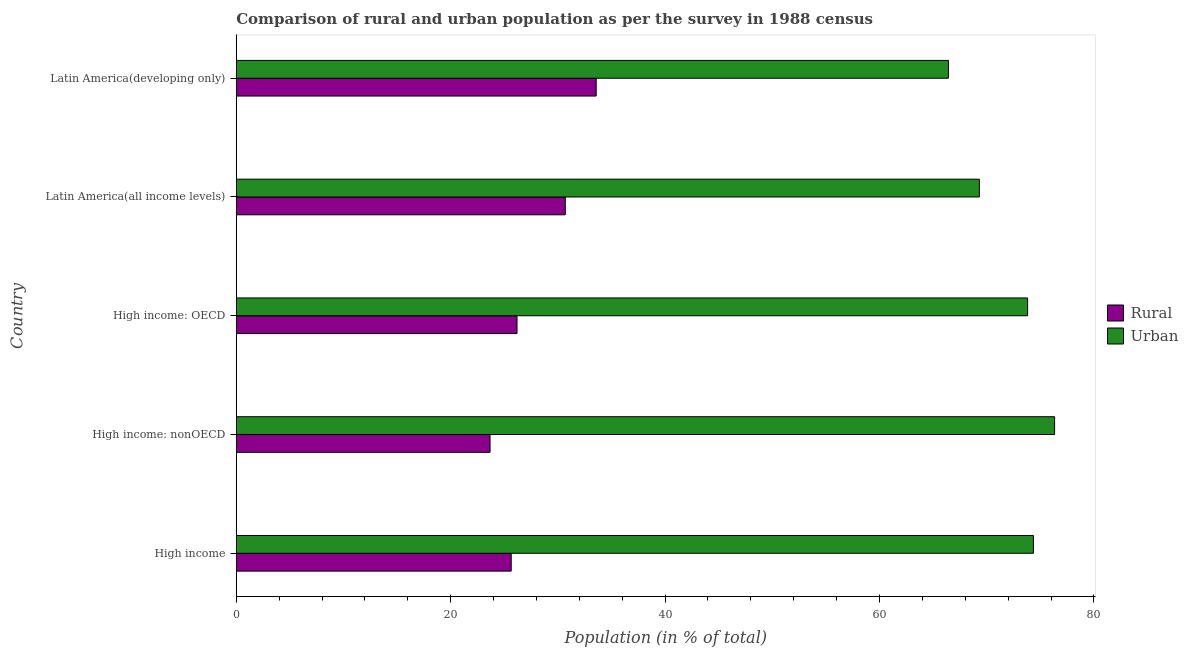How many different coloured bars are there?
Offer a terse response. 2. Are the number of bars per tick equal to the number of legend labels?
Keep it short and to the point. Yes. Are the number of bars on each tick of the Y-axis equal?
Provide a succinct answer. Yes. How many bars are there on the 2nd tick from the top?
Make the answer very short. 2. What is the rural population in High income: nonOECD?
Your response must be concise. 23.67. Across all countries, what is the maximum urban population?
Offer a terse response. 76.33. Across all countries, what is the minimum rural population?
Your answer should be very brief. 23.67. In which country was the rural population maximum?
Make the answer very short. Latin America(developing only). In which country was the rural population minimum?
Offer a terse response. High income: nonOECD. What is the total urban population in the graph?
Keep it short and to the point. 360.23. What is the difference between the urban population in High income: OECD and that in Latin America(all income levels)?
Your response must be concise. 4.5. What is the difference between the rural population in High income: OECD and the urban population in High income: nonOECD?
Make the answer very short. -50.14. What is the average rural population per country?
Provide a short and direct response. 27.95. What is the difference between the urban population and rural population in High income?
Offer a terse response. 48.71. In how many countries, is the rural population greater than 40 %?
Provide a short and direct response. 0. What is the ratio of the rural population in High income to that in Latin America(developing only)?
Your response must be concise. 0.76. Is the urban population in High income: OECD less than that in High income: nonOECD?
Your answer should be very brief. Yes. Is the difference between the urban population in High income and High income: nonOECD greater than the difference between the rural population in High income and High income: nonOECD?
Your answer should be compact. No. What is the difference between the highest and the second highest urban population?
Give a very brief answer. 1.98. What is the difference between the highest and the lowest rural population?
Make the answer very short. 9.9. In how many countries, is the rural population greater than the average rural population taken over all countries?
Ensure brevity in your answer.  2. Is the sum of the rural population in High income: OECD and High income: nonOECD greater than the maximum urban population across all countries?
Offer a terse response. No. What does the 1st bar from the top in Latin America(all income levels) represents?
Provide a succinct answer. Urban. What does the 2nd bar from the bottom in Latin America(developing only) represents?
Keep it short and to the point. Urban. How many bars are there?
Keep it short and to the point. 10. How many countries are there in the graph?
Your response must be concise. 5. Does the graph contain grids?
Your response must be concise. No. Where does the legend appear in the graph?
Offer a terse response. Center right. How are the legend labels stacked?
Offer a very short reply. Vertical. What is the title of the graph?
Keep it short and to the point. Comparison of rural and urban population as per the survey in 1988 census. What is the label or title of the X-axis?
Offer a very short reply. Population (in % of total). What is the Population (in % of total) in Rural in High income?
Ensure brevity in your answer.  25.65. What is the Population (in % of total) in Urban in High income?
Offer a very short reply. 74.35. What is the Population (in % of total) in Rural in High income: nonOECD?
Your response must be concise. 23.67. What is the Population (in % of total) in Urban in High income: nonOECD?
Offer a very short reply. 76.33. What is the Population (in % of total) in Rural in High income: OECD?
Offer a terse response. 26.19. What is the Population (in % of total) of Urban in High income: OECD?
Give a very brief answer. 73.81. What is the Population (in % of total) of Rural in Latin America(all income levels)?
Provide a short and direct response. 30.69. What is the Population (in % of total) of Urban in Latin America(all income levels)?
Your response must be concise. 69.31. What is the Population (in % of total) in Rural in Latin America(developing only)?
Your response must be concise. 33.57. What is the Population (in % of total) in Urban in Latin America(developing only)?
Your answer should be very brief. 66.43. Across all countries, what is the maximum Population (in % of total) of Rural?
Provide a short and direct response. 33.57. Across all countries, what is the maximum Population (in % of total) of Urban?
Give a very brief answer. 76.33. Across all countries, what is the minimum Population (in % of total) of Rural?
Make the answer very short. 23.67. Across all countries, what is the minimum Population (in % of total) of Urban?
Your response must be concise. 66.43. What is the total Population (in % of total) in Rural in the graph?
Provide a short and direct response. 139.77. What is the total Population (in % of total) of Urban in the graph?
Your answer should be very brief. 360.23. What is the difference between the Population (in % of total) of Rural in High income and that in High income: nonOECD?
Your answer should be very brief. 1.98. What is the difference between the Population (in % of total) in Urban in High income and that in High income: nonOECD?
Offer a terse response. -1.98. What is the difference between the Population (in % of total) of Rural in High income and that in High income: OECD?
Your answer should be compact. -0.54. What is the difference between the Population (in % of total) of Urban in High income and that in High income: OECD?
Offer a very short reply. 0.54. What is the difference between the Population (in % of total) in Rural in High income and that in Latin America(all income levels)?
Provide a short and direct response. -5.04. What is the difference between the Population (in % of total) of Urban in High income and that in Latin America(all income levels)?
Your response must be concise. 5.04. What is the difference between the Population (in % of total) of Rural in High income and that in Latin America(developing only)?
Your response must be concise. -7.93. What is the difference between the Population (in % of total) of Urban in High income and that in Latin America(developing only)?
Your response must be concise. 7.93. What is the difference between the Population (in % of total) of Rural in High income: nonOECD and that in High income: OECD?
Offer a terse response. -2.52. What is the difference between the Population (in % of total) of Urban in High income: nonOECD and that in High income: OECD?
Provide a succinct answer. 2.52. What is the difference between the Population (in % of total) of Rural in High income: nonOECD and that in Latin America(all income levels)?
Offer a very short reply. -7.02. What is the difference between the Population (in % of total) of Urban in High income: nonOECD and that in Latin America(all income levels)?
Ensure brevity in your answer.  7.02. What is the difference between the Population (in % of total) in Rural in High income: nonOECD and that in Latin America(developing only)?
Your response must be concise. -9.9. What is the difference between the Population (in % of total) of Urban in High income: nonOECD and that in Latin America(developing only)?
Your answer should be very brief. 9.9. What is the difference between the Population (in % of total) of Rural in High income: OECD and that in Latin America(all income levels)?
Your answer should be very brief. -4.5. What is the difference between the Population (in % of total) of Urban in High income: OECD and that in Latin America(all income levels)?
Offer a very short reply. 4.5. What is the difference between the Population (in % of total) in Rural in High income: OECD and that in Latin America(developing only)?
Make the answer very short. -7.38. What is the difference between the Population (in % of total) of Urban in High income: OECD and that in Latin America(developing only)?
Your answer should be compact. 7.38. What is the difference between the Population (in % of total) in Rural in Latin America(all income levels) and that in Latin America(developing only)?
Offer a very short reply. -2.88. What is the difference between the Population (in % of total) in Urban in Latin America(all income levels) and that in Latin America(developing only)?
Make the answer very short. 2.88. What is the difference between the Population (in % of total) of Rural in High income and the Population (in % of total) of Urban in High income: nonOECD?
Make the answer very short. -50.68. What is the difference between the Population (in % of total) in Rural in High income and the Population (in % of total) in Urban in High income: OECD?
Your response must be concise. -48.17. What is the difference between the Population (in % of total) of Rural in High income and the Population (in % of total) of Urban in Latin America(all income levels)?
Your answer should be compact. -43.66. What is the difference between the Population (in % of total) in Rural in High income and the Population (in % of total) in Urban in Latin America(developing only)?
Offer a very short reply. -40.78. What is the difference between the Population (in % of total) in Rural in High income: nonOECD and the Population (in % of total) in Urban in High income: OECD?
Your answer should be compact. -50.14. What is the difference between the Population (in % of total) in Rural in High income: nonOECD and the Population (in % of total) in Urban in Latin America(all income levels)?
Your answer should be compact. -45.64. What is the difference between the Population (in % of total) of Rural in High income: nonOECD and the Population (in % of total) of Urban in Latin America(developing only)?
Make the answer very short. -42.76. What is the difference between the Population (in % of total) of Rural in High income: OECD and the Population (in % of total) of Urban in Latin America(all income levels)?
Offer a very short reply. -43.12. What is the difference between the Population (in % of total) in Rural in High income: OECD and the Population (in % of total) in Urban in Latin America(developing only)?
Provide a succinct answer. -40.24. What is the difference between the Population (in % of total) of Rural in Latin America(all income levels) and the Population (in % of total) of Urban in Latin America(developing only)?
Provide a succinct answer. -35.74. What is the average Population (in % of total) in Rural per country?
Give a very brief answer. 27.95. What is the average Population (in % of total) in Urban per country?
Provide a succinct answer. 72.05. What is the difference between the Population (in % of total) of Rural and Population (in % of total) of Urban in High income?
Ensure brevity in your answer.  -48.71. What is the difference between the Population (in % of total) in Rural and Population (in % of total) in Urban in High income: nonOECD?
Your response must be concise. -52.66. What is the difference between the Population (in % of total) in Rural and Population (in % of total) in Urban in High income: OECD?
Your response must be concise. -47.62. What is the difference between the Population (in % of total) in Rural and Population (in % of total) in Urban in Latin America(all income levels)?
Your response must be concise. -38.62. What is the difference between the Population (in % of total) in Rural and Population (in % of total) in Urban in Latin America(developing only)?
Offer a very short reply. -32.86. What is the ratio of the Population (in % of total) of Rural in High income to that in High income: nonOECD?
Keep it short and to the point. 1.08. What is the ratio of the Population (in % of total) in Urban in High income to that in High income: nonOECD?
Your response must be concise. 0.97. What is the ratio of the Population (in % of total) in Rural in High income to that in High income: OECD?
Keep it short and to the point. 0.98. What is the ratio of the Population (in % of total) of Urban in High income to that in High income: OECD?
Offer a very short reply. 1.01. What is the ratio of the Population (in % of total) of Rural in High income to that in Latin America(all income levels)?
Provide a succinct answer. 0.84. What is the ratio of the Population (in % of total) of Urban in High income to that in Latin America(all income levels)?
Your answer should be very brief. 1.07. What is the ratio of the Population (in % of total) of Rural in High income to that in Latin America(developing only)?
Ensure brevity in your answer.  0.76. What is the ratio of the Population (in % of total) in Urban in High income to that in Latin America(developing only)?
Your answer should be compact. 1.12. What is the ratio of the Population (in % of total) in Rural in High income: nonOECD to that in High income: OECD?
Your response must be concise. 0.9. What is the ratio of the Population (in % of total) of Urban in High income: nonOECD to that in High income: OECD?
Provide a succinct answer. 1.03. What is the ratio of the Population (in % of total) of Rural in High income: nonOECD to that in Latin America(all income levels)?
Ensure brevity in your answer.  0.77. What is the ratio of the Population (in % of total) of Urban in High income: nonOECD to that in Latin America(all income levels)?
Your answer should be compact. 1.1. What is the ratio of the Population (in % of total) in Rural in High income: nonOECD to that in Latin America(developing only)?
Keep it short and to the point. 0.71. What is the ratio of the Population (in % of total) of Urban in High income: nonOECD to that in Latin America(developing only)?
Your answer should be compact. 1.15. What is the ratio of the Population (in % of total) of Rural in High income: OECD to that in Latin America(all income levels)?
Provide a succinct answer. 0.85. What is the ratio of the Population (in % of total) in Urban in High income: OECD to that in Latin America(all income levels)?
Offer a terse response. 1.06. What is the ratio of the Population (in % of total) of Rural in High income: OECD to that in Latin America(developing only)?
Offer a terse response. 0.78. What is the ratio of the Population (in % of total) of Urban in High income: OECD to that in Latin America(developing only)?
Keep it short and to the point. 1.11. What is the ratio of the Population (in % of total) of Rural in Latin America(all income levels) to that in Latin America(developing only)?
Ensure brevity in your answer.  0.91. What is the ratio of the Population (in % of total) in Urban in Latin America(all income levels) to that in Latin America(developing only)?
Offer a terse response. 1.04. What is the difference between the highest and the second highest Population (in % of total) in Rural?
Give a very brief answer. 2.88. What is the difference between the highest and the second highest Population (in % of total) in Urban?
Offer a very short reply. 1.98. What is the difference between the highest and the lowest Population (in % of total) in Rural?
Provide a short and direct response. 9.9. What is the difference between the highest and the lowest Population (in % of total) of Urban?
Your answer should be compact. 9.9. 